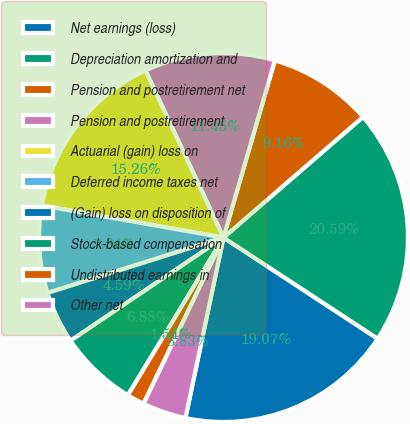Convert chart to OTSL. <chart><loc_0><loc_0><loc_500><loc_500><pie_chart><fcel>Net earnings (loss)<fcel>Depreciation amortization and<fcel>Pension and postretirement net<fcel>Pension and postretirement<fcel>Actuarial (gain) loss on<fcel>Deferred income taxes net<fcel>(Gain) loss on disposition of<fcel>Stock-based compensation<fcel>Undistributed earnings in<fcel>Other net<nl><fcel>19.07%<fcel>20.59%<fcel>9.16%<fcel>11.45%<fcel>15.26%<fcel>7.64%<fcel>4.59%<fcel>6.88%<fcel>1.54%<fcel>3.83%<nl></chart> 